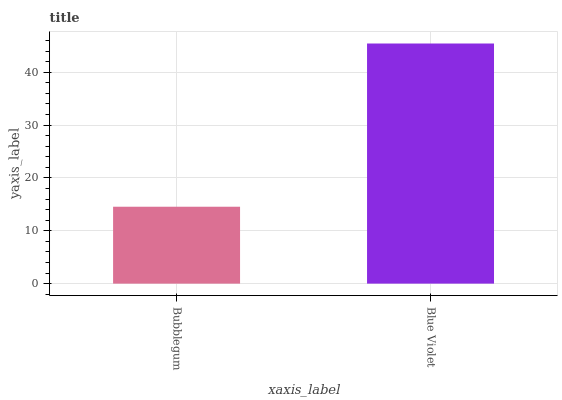Is Blue Violet the minimum?
Answer yes or no. No. Is Blue Violet greater than Bubblegum?
Answer yes or no. Yes. Is Bubblegum less than Blue Violet?
Answer yes or no. Yes. Is Bubblegum greater than Blue Violet?
Answer yes or no. No. Is Blue Violet less than Bubblegum?
Answer yes or no. No. Is Blue Violet the high median?
Answer yes or no. Yes. Is Bubblegum the low median?
Answer yes or no. Yes. Is Bubblegum the high median?
Answer yes or no. No. Is Blue Violet the low median?
Answer yes or no. No. 